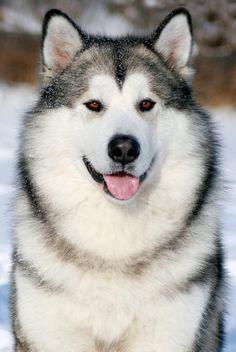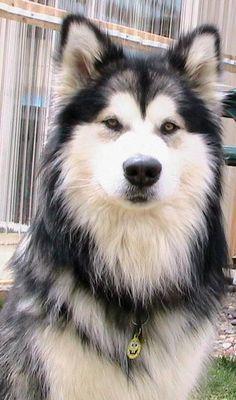The first image is the image on the left, the second image is the image on the right. Evaluate the accuracy of this statement regarding the images: "The right image features a dog with dark fur framing a white-furred face and snow on some of its fur.". Is it true? Answer yes or no. No. The first image is the image on the left, the second image is the image on the right. Analyze the images presented: Is the assertion "There is exactly one dog outside in the snow in every photo, and both dogs either have their mouths closed or they both have them open." valid? Answer yes or no. No. 